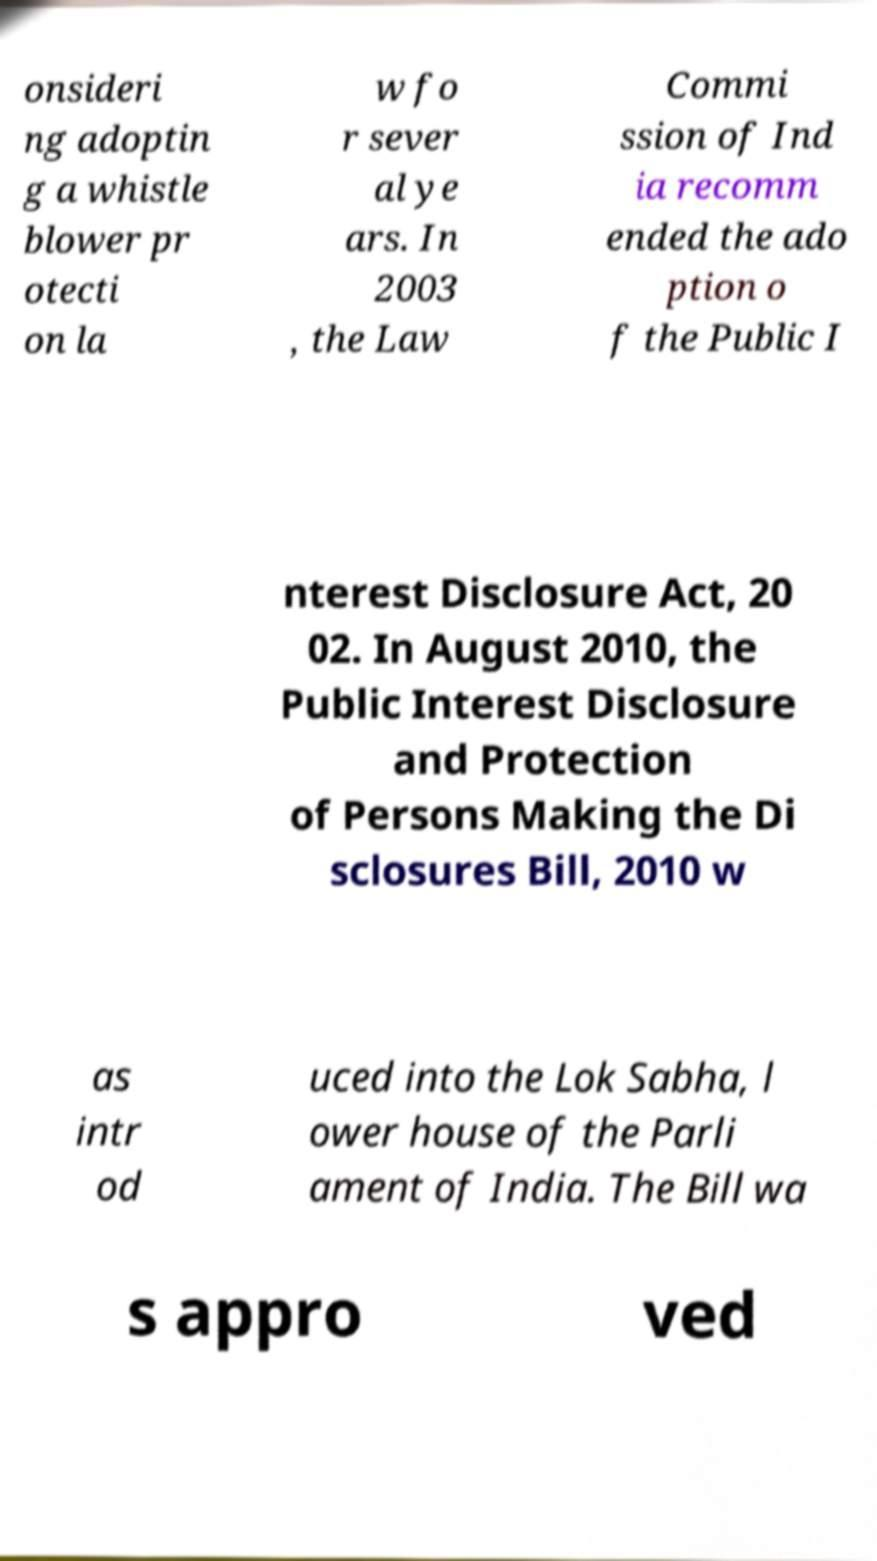Can you accurately transcribe the text from the provided image for me? onsideri ng adoptin g a whistle blower pr otecti on la w fo r sever al ye ars. In 2003 , the Law Commi ssion of Ind ia recomm ended the ado ption o f the Public I nterest Disclosure Act, 20 02. In August 2010, the Public Interest Disclosure and Protection of Persons Making the Di sclosures Bill, 2010 w as intr od uced into the Lok Sabha, l ower house of the Parli ament of India. The Bill wa s appro ved 